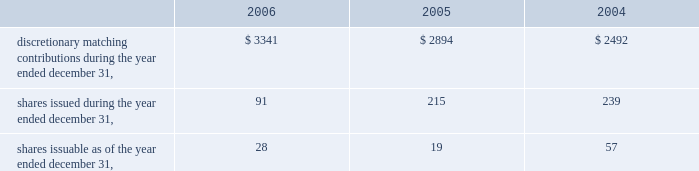Vertex pharmaceuticals incorporated notes to consolidated financial statements ( continued ) o .
Significant revenue arrangements ( continued ) $ 7 million of development and commercialization milestone payments .
Additionally , kissei agreed to reimburse the company for certain development costs , including a portion of costs for phase 2 trials of vx-702 .
Research funding ended under this program in june 2000 , and the company has received the full amount of research funding specified under the agreement .
Kissei has exclusive rights to develop and commercialize vx-702 in japan and certain far east countries and co-exclusive rights in china , taiwan and south korea .
The company retains exclusive marketing rights outside the far east and co-exclusive rights in china , taiwan and south korea .
In addition , the company will have the right to supply bulk drug material to kissei for sale in its territory and will receive royalties or drug supply payments on future product sales , if any .
In 2006 , 2005 and 2004 , approximately $ 6.4 million , $ 7.3 million and $ 3.5 million , respectively , was recognized as revenue under this agreement .
The $ 7.3 million of revenue recognized in 2005 includes a $ 2.5 million milestone paid upon kissei 2019s completion of regulatory filings in preparation for phase 1 clinical development of vx-702 in japan .
Employee benefits the company has a 401 ( k ) retirement plan ( the 201cvertex 401 ( k ) plan 201d ) in which substantially all of its permanent employees are eligible to participate .
Participants may contribute up to 60% ( 60 % ) of their annual compensation to the vertex 401 ( k ) plan , subject to statutory limitations .
The company may declare discretionary matching contributions to the vertex 401 ( k ) plan that are payable in the form of vertex common stock .
The match is paid in the form of fully vested interests in a vertex common stock fund .
Employees have the ability to transfer funds from the company stock fund as they choose .
The company declared matching contributions to the vertex 401 ( k ) plan as follows ( in thousands ) : q .
Related party transactions as of december 31 , 2006 , 2005 and 2004 , the company had a loan outstanding to a former officer of the company in the amount of $ 36000 , $ 36000 , $ 97000 , respectively , which was initially advanced in april 2002 .
The loan balance is included in other assets on the consolidated balance sheets .
In 2001 , the company entered into a four year consulting agreement with a director of the company for the provision of part-time consulting services over a period of four years , at the rate of $ 80000 per year commencing in january 2002 .
The consulting agreement terminated in january 2006 .
Contingencies the company has certain contingent liabilities that arise in the ordinary course of its business activities .
The company accrues a reserve for contingent liabilities when it is probable that future expenditures will be made and such expenditures can be reasonably estimated. .
Discretionary matching contributions during the year ended december 31 , $ 3341 $ 2894 $ 2492 shares issued during the year ended december 31 , 91 215 239 shares issuable as of the year ended december 31 , 28 19 57 .
What was the percent change in revenue recognized under the agreement between 2004and 2005? 
Computations: ((7.3 - 3.5) / 3.5)
Answer: 1.08571. 